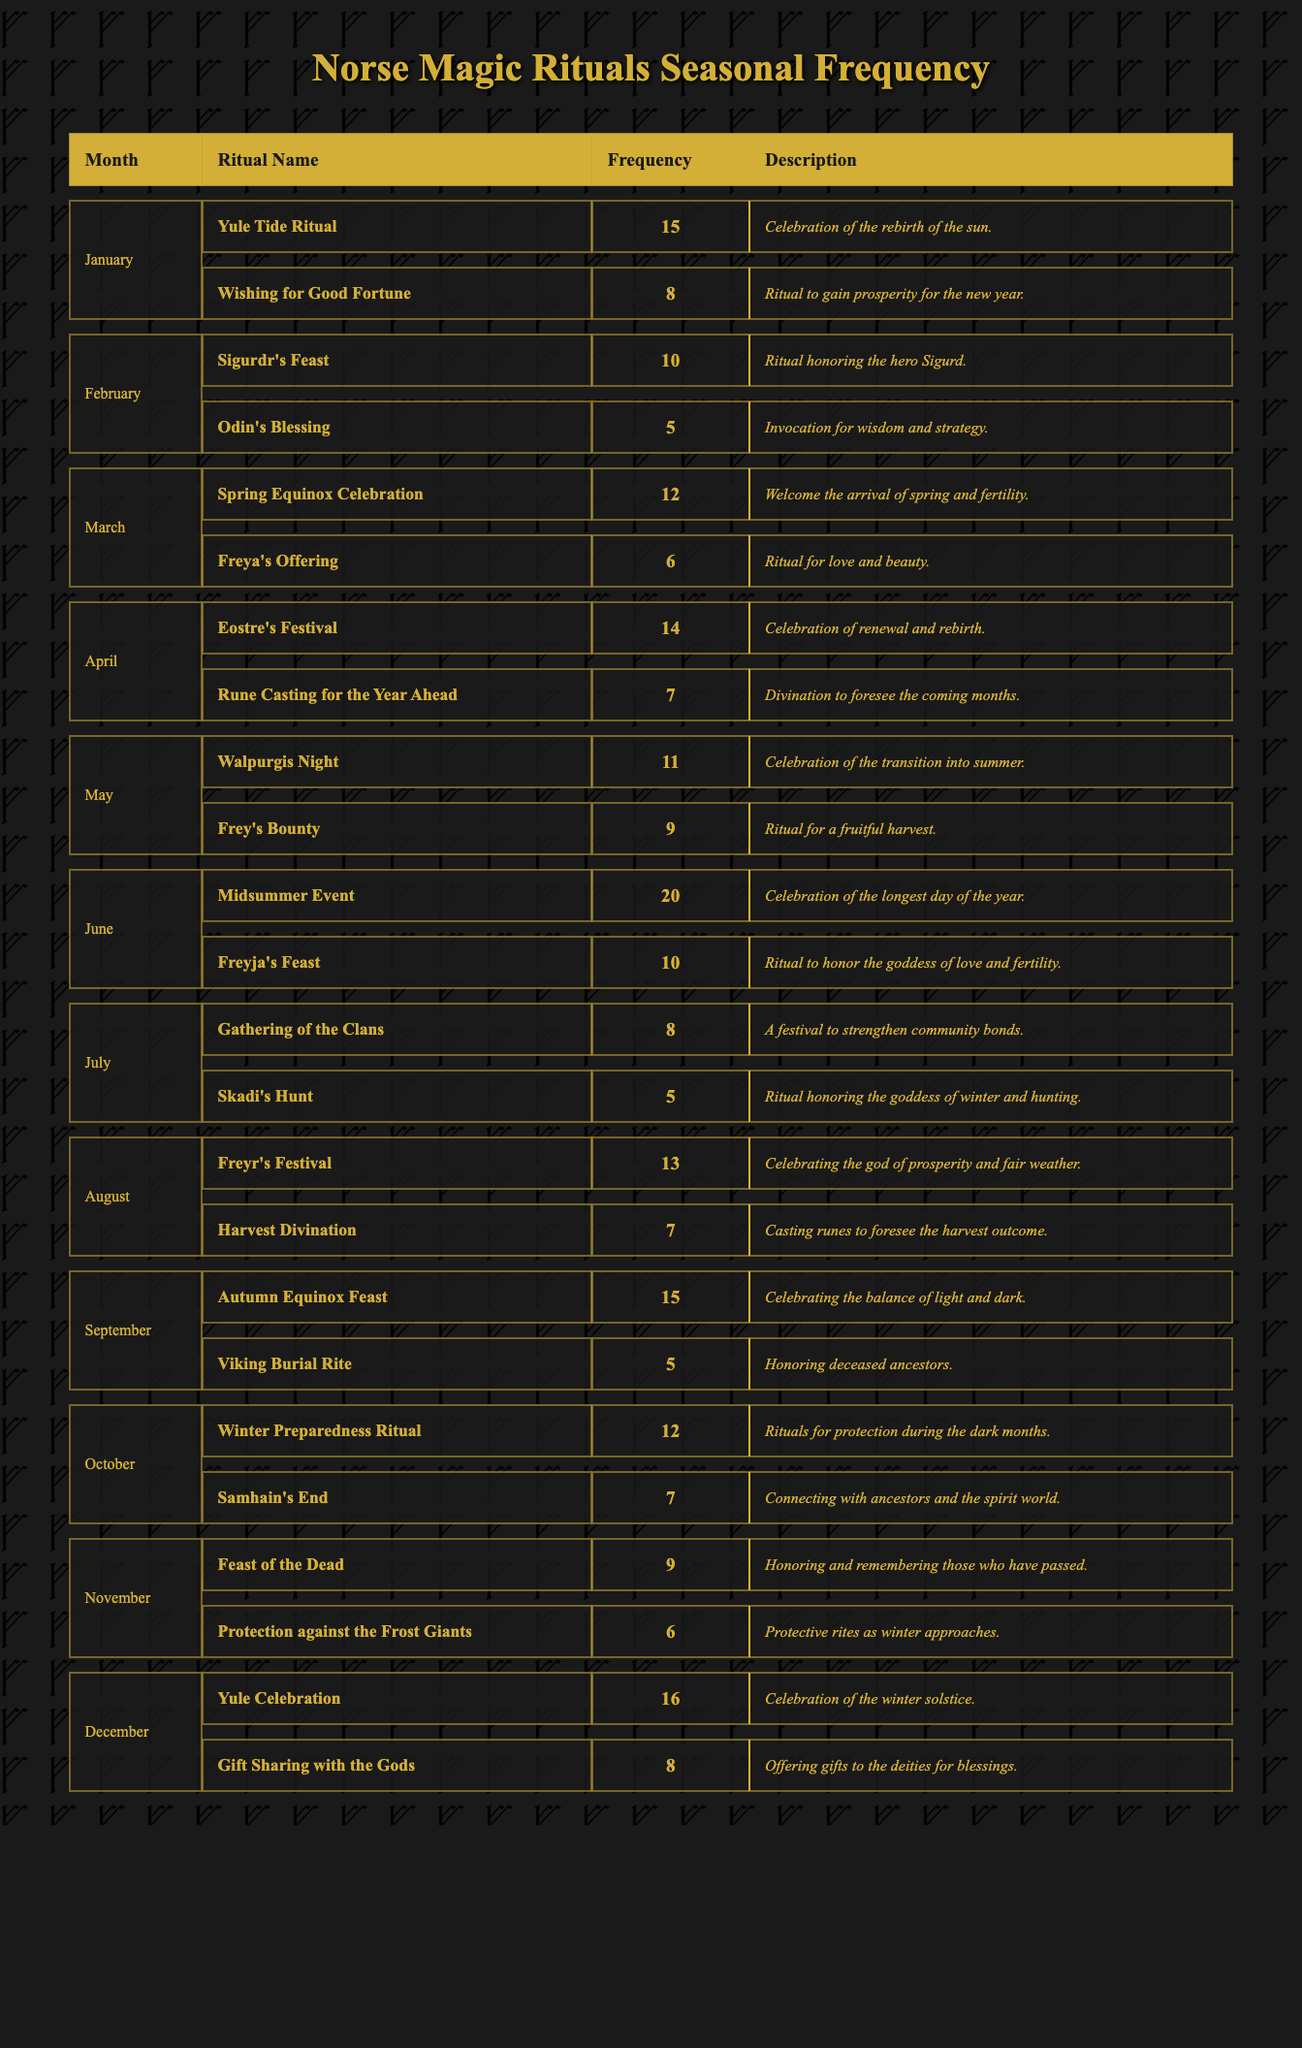What is the ritual with the highest frequency in June? The table shows that in June, the ritual "Midsummer Event" has the highest frequency of 20, while the other ritual "Freyja's Feast" has a frequency of 10.
Answer: Midsummer Event Which month has the most rituals listed? Upon checking each month's rituals, January, February, March, April, May, June, July, August, September, October, November, and December all have 2 rituals listed, hence no month has more than 2.
Answer: No month has more than 2 rituals What is the total frequency of rituals performed in May? In May, the frequency of "Walpurgis Night" is 11 and "Frey's Bounty" is 9. The total frequency is calculated as 11 + 9 = 20.
Answer: 20 Did more rituals take place in December than in January? December has a total frequency of 16 (Yule Celebration 16, Gift Sharing with the Gods 8), while January has a total frequency of 23 (Yule Tide Ritual 15, Wishing for Good Fortune 8). Therefore, more rituals occurred in January.
Answer: No What is the average frequency of rituals held in the months of the summer? For June (20), July (13), and August (20), the total frequency is calculated as 20 + 10 + 20 = 50. There are 3 months, so the average frequency is 50 / 3 = 16.67.
Answer: 16.67 Which ritual is specifically for protection during winter, and what is its frequency? The ritual "Winter Preparedness Ritual" specifically mentions protection during the dark months, and its frequency is 12.
Answer: Winter Preparedness Ritual, frequency of 12 Which two rituals are performed with the same frequency in different months, and what is that frequency? The rituals "Samhain's End" and "Skadi's Hunt" both have a frequency of 7, although they are in different months (October and July, respectively).
Answer: Frequency of 7 What is the frequency difference between the most and least performed rituals in September? In September, "Autumn Equinox Feast" has the highest frequency of 15, while "Viking Burial Rite" has a frequency of 5. The difference is 15 - 5 = 10.
Answer: 10 What is the significance of the "Rune Casting for the Year Ahead" ritual? This ritual specifically relates to divination intended to foresee the coming months and holds a frequency of 7 in April.
Answer: Divination, frequency 7 How many rituals were performed during the transition from winter to summer? The transition from winter to summer includes rituals from April (Eostre's Festival 14 and Rune Casting for the Year Ahead 7) and May (Walpurgis Night 11 and Frey's Bounty 9), totaling 14 + 7 + 11 + 9 = 41.
Answer: 41 